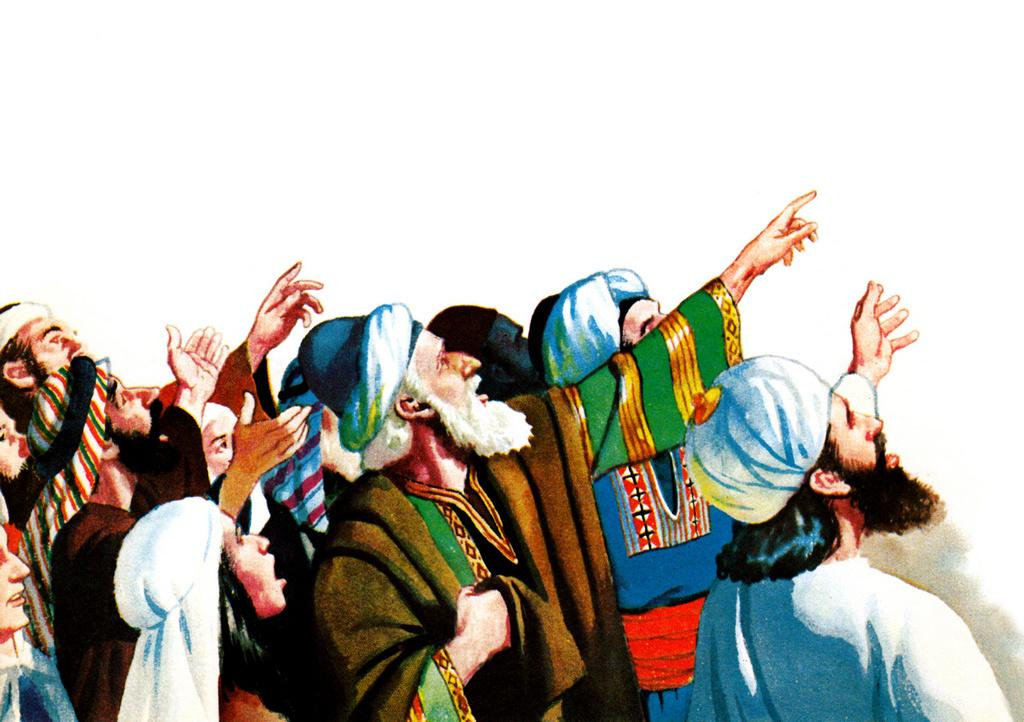What is the main subject of the image? There is a painting in the image. What is shown in the painting? The painting depicts people. What type of potato is being used as a sheet in the image? There is no potato or sheet present in the image; it only features a painting depicting people. 